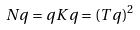Convert formula to latex. <formula><loc_0><loc_0><loc_500><loc_500>N q = q K q = ( T q ) ^ { 2 }</formula> 